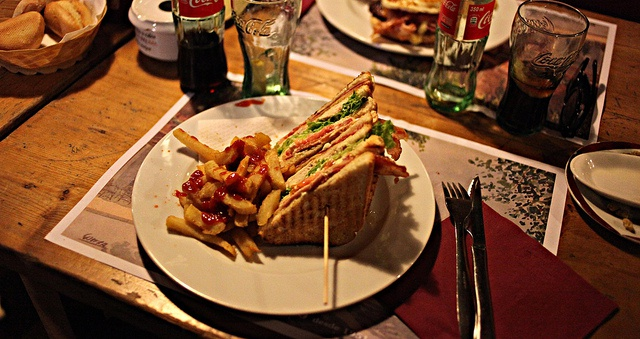Describe the objects in this image and their specific colors. I can see dining table in maroon, black, tan, and brown tones, sandwich in maroon, black, orange, and brown tones, cup in maroon, black, and brown tones, bowl in black, maroon, brown, and orange tones, and bottle in maroon, black, olive, and brown tones in this image. 